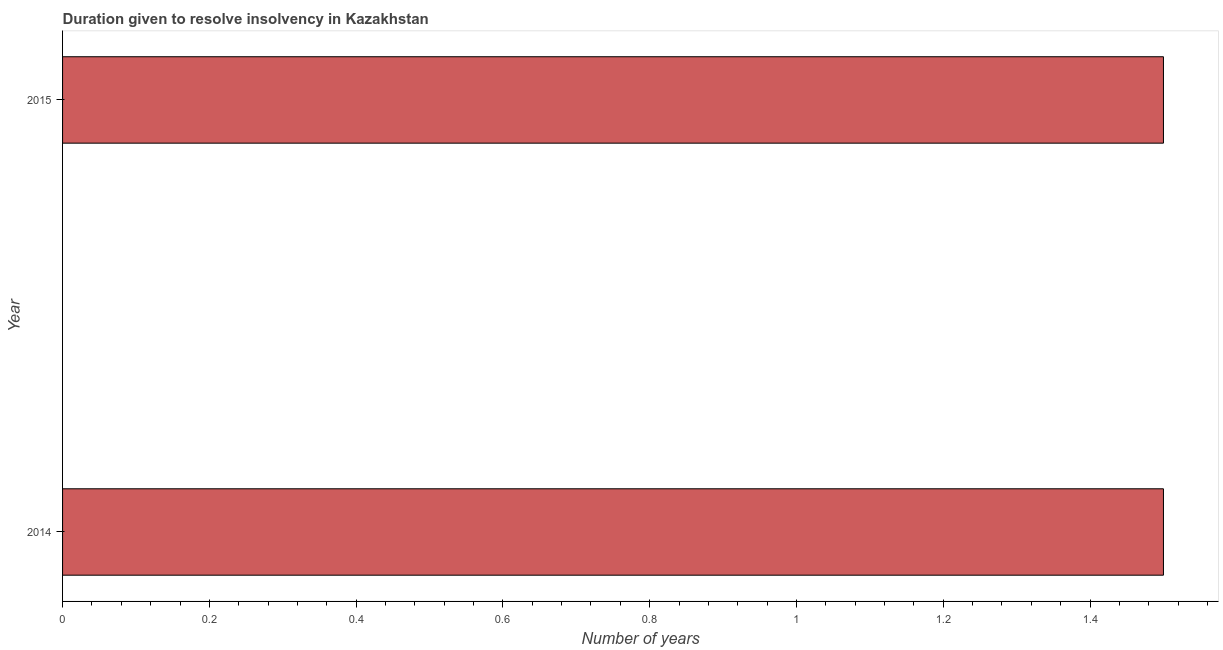Does the graph contain grids?
Provide a succinct answer. No. What is the title of the graph?
Give a very brief answer. Duration given to resolve insolvency in Kazakhstan. What is the label or title of the X-axis?
Your answer should be compact. Number of years. Across all years, what is the maximum number of years to resolve insolvency?
Make the answer very short. 1.5. Across all years, what is the minimum number of years to resolve insolvency?
Provide a succinct answer. 1.5. In which year was the number of years to resolve insolvency minimum?
Your response must be concise. 2014. What is the sum of the number of years to resolve insolvency?
Offer a very short reply. 3. What is the average number of years to resolve insolvency per year?
Provide a short and direct response. 1.5. What is the median number of years to resolve insolvency?
Give a very brief answer. 1.5. What is the ratio of the number of years to resolve insolvency in 2014 to that in 2015?
Make the answer very short. 1. Is the number of years to resolve insolvency in 2014 less than that in 2015?
Your answer should be compact. No. Are all the bars in the graph horizontal?
Ensure brevity in your answer.  Yes. What is the difference between two consecutive major ticks on the X-axis?
Ensure brevity in your answer.  0.2. What is the Number of years in 2014?
Your answer should be very brief. 1.5. 